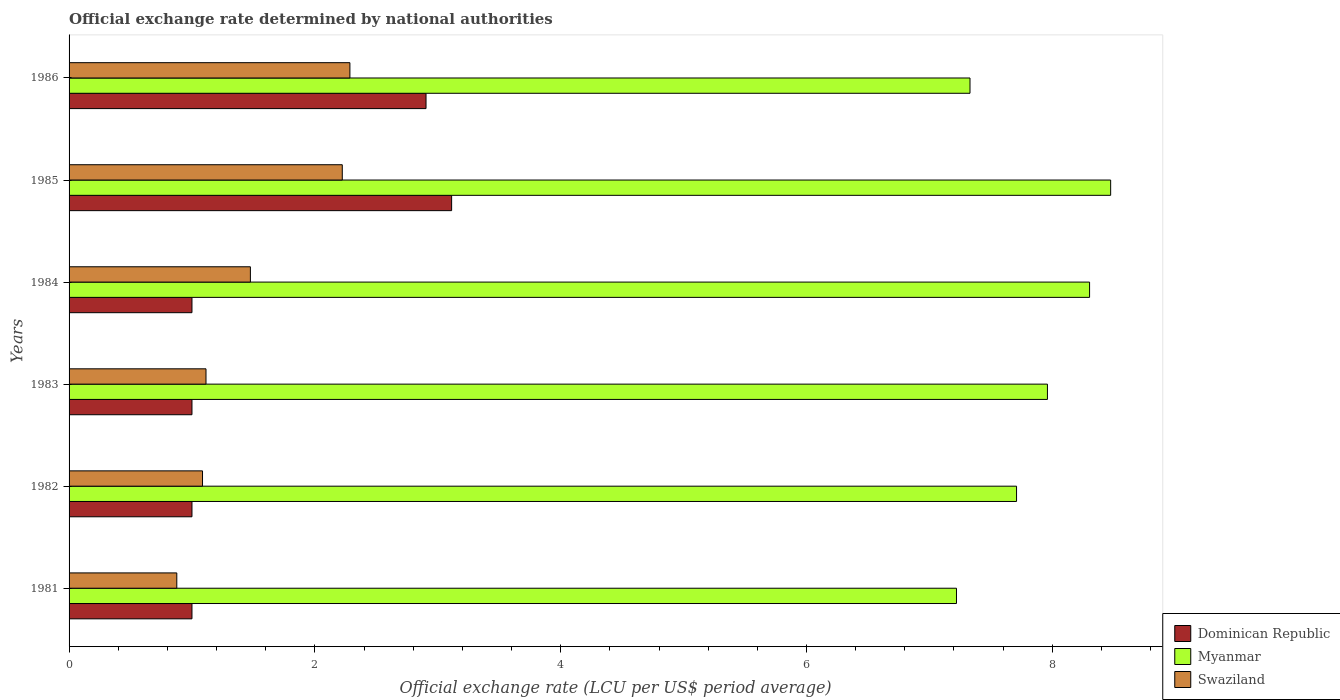Are the number of bars per tick equal to the number of legend labels?
Make the answer very short. Yes. What is the label of the 6th group of bars from the top?
Provide a succinct answer. 1981. In how many cases, is the number of bars for a given year not equal to the number of legend labels?
Your answer should be very brief. 0. What is the official exchange rate in Swaziland in 1982?
Offer a very short reply. 1.09. Across all years, what is the maximum official exchange rate in Myanmar?
Provide a short and direct response. 8.47. Across all years, what is the minimum official exchange rate in Swaziland?
Ensure brevity in your answer.  0.88. In which year was the official exchange rate in Swaziland maximum?
Your answer should be very brief. 1986. In which year was the official exchange rate in Swaziland minimum?
Offer a very short reply. 1981. What is the total official exchange rate in Myanmar in the graph?
Keep it short and to the point. 47. What is the difference between the official exchange rate in Swaziland in 1982 and that in 1984?
Give a very brief answer. -0.39. What is the difference between the official exchange rate in Myanmar in 1981 and the official exchange rate in Swaziland in 1983?
Keep it short and to the point. 6.11. What is the average official exchange rate in Myanmar per year?
Provide a short and direct response. 7.83. In the year 1981, what is the difference between the official exchange rate in Swaziland and official exchange rate in Myanmar?
Provide a short and direct response. -6.34. Is the official exchange rate in Myanmar in 1981 less than that in 1983?
Make the answer very short. Yes. What is the difference between the highest and the second highest official exchange rate in Swaziland?
Keep it short and to the point. 0.06. What is the difference between the highest and the lowest official exchange rate in Swaziland?
Provide a succinct answer. 1.41. In how many years, is the official exchange rate in Dominican Republic greater than the average official exchange rate in Dominican Republic taken over all years?
Offer a very short reply. 2. Is the sum of the official exchange rate in Swaziland in 1983 and 1984 greater than the maximum official exchange rate in Dominican Republic across all years?
Provide a short and direct response. No. What does the 1st bar from the top in 1981 represents?
Your answer should be very brief. Swaziland. What does the 3rd bar from the bottom in 1985 represents?
Offer a very short reply. Swaziland. How many bars are there?
Provide a succinct answer. 18. Are all the bars in the graph horizontal?
Offer a very short reply. Yes. What is the difference between two consecutive major ticks on the X-axis?
Provide a succinct answer. 2. Are the values on the major ticks of X-axis written in scientific E-notation?
Give a very brief answer. No. Where does the legend appear in the graph?
Provide a succinct answer. Bottom right. What is the title of the graph?
Make the answer very short. Official exchange rate determined by national authorities. What is the label or title of the X-axis?
Give a very brief answer. Official exchange rate (LCU per US$ period average). What is the label or title of the Y-axis?
Make the answer very short. Years. What is the Official exchange rate (LCU per US$ period average) of Dominican Republic in 1981?
Your answer should be compact. 1. What is the Official exchange rate (LCU per US$ period average) in Myanmar in 1981?
Give a very brief answer. 7.22. What is the Official exchange rate (LCU per US$ period average) in Swaziland in 1981?
Keep it short and to the point. 0.88. What is the Official exchange rate (LCU per US$ period average) of Dominican Republic in 1982?
Provide a succinct answer. 1. What is the Official exchange rate (LCU per US$ period average) of Myanmar in 1982?
Provide a short and direct response. 7.71. What is the Official exchange rate (LCU per US$ period average) of Swaziland in 1982?
Make the answer very short. 1.09. What is the Official exchange rate (LCU per US$ period average) of Dominican Republic in 1983?
Provide a short and direct response. 1. What is the Official exchange rate (LCU per US$ period average) in Myanmar in 1983?
Provide a short and direct response. 7.96. What is the Official exchange rate (LCU per US$ period average) in Swaziland in 1983?
Provide a succinct answer. 1.11. What is the Official exchange rate (LCU per US$ period average) of Dominican Republic in 1984?
Give a very brief answer. 1. What is the Official exchange rate (LCU per US$ period average) of Myanmar in 1984?
Keep it short and to the point. 8.3. What is the Official exchange rate (LCU per US$ period average) in Swaziland in 1984?
Ensure brevity in your answer.  1.48. What is the Official exchange rate (LCU per US$ period average) of Dominican Republic in 1985?
Make the answer very short. 3.11. What is the Official exchange rate (LCU per US$ period average) of Myanmar in 1985?
Keep it short and to the point. 8.47. What is the Official exchange rate (LCU per US$ period average) in Swaziland in 1985?
Your response must be concise. 2.22. What is the Official exchange rate (LCU per US$ period average) in Dominican Republic in 1986?
Give a very brief answer. 2.9. What is the Official exchange rate (LCU per US$ period average) of Myanmar in 1986?
Your response must be concise. 7.33. What is the Official exchange rate (LCU per US$ period average) in Swaziland in 1986?
Make the answer very short. 2.29. Across all years, what is the maximum Official exchange rate (LCU per US$ period average) of Dominican Republic?
Make the answer very short. 3.11. Across all years, what is the maximum Official exchange rate (LCU per US$ period average) of Myanmar?
Your response must be concise. 8.47. Across all years, what is the maximum Official exchange rate (LCU per US$ period average) in Swaziland?
Offer a very short reply. 2.29. Across all years, what is the minimum Official exchange rate (LCU per US$ period average) in Dominican Republic?
Offer a very short reply. 1. Across all years, what is the minimum Official exchange rate (LCU per US$ period average) of Myanmar?
Give a very brief answer. 7.22. Across all years, what is the minimum Official exchange rate (LCU per US$ period average) in Swaziland?
Offer a terse response. 0.88. What is the total Official exchange rate (LCU per US$ period average) of Dominican Republic in the graph?
Provide a succinct answer. 10.02. What is the total Official exchange rate (LCU per US$ period average) of Myanmar in the graph?
Provide a short and direct response. 47. What is the total Official exchange rate (LCU per US$ period average) in Swaziland in the graph?
Provide a succinct answer. 9.06. What is the difference between the Official exchange rate (LCU per US$ period average) of Myanmar in 1981 and that in 1982?
Offer a very short reply. -0.49. What is the difference between the Official exchange rate (LCU per US$ period average) in Swaziland in 1981 and that in 1982?
Your response must be concise. -0.21. What is the difference between the Official exchange rate (LCU per US$ period average) in Dominican Republic in 1981 and that in 1983?
Make the answer very short. 0. What is the difference between the Official exchange rate (LCU per US$ period average) of Myanmar in 1981 and that in 1983?
Provide a short and direct response. -0.74. What is the difference between the Official exchange rate (LCU per US$ period average) of Swaziland in 1981 and that in 1983?
Provide a succinct answer. -0.24. What is the difference between the Official exchange rate (LCU per US$ period average) of Dominican Republic in 1981 and that in 1984?
Your answer should be very brief. -0. What is the difference between the Official exchange rate (LCU per US$ period average) in Myanmar in 1981 and that in 1984?
Make the answer very short. -1.08. What is the difference between the Official exchange rate (LCU per US$ period average) in Swaziland in 1981 and that in 1984?
Offer a very short reply. -0.6. What is the difference between the Official exchange rate (LCU per US$ period average) of Dominican Republic in 1981 and that in 1985?
Your answer should be compact. -2.11. What is the difference between the Official exchange rate (LCU per US$ period average) in Myanmar in 1981 and that in 1985?
Offer a terse response. -1.25. What is the difference between the Official exchange rate (LCU per US$ period average) of Swaziland in 1981 and that in 1985?
Keep it short and to the point. -1.35. What is the difference between the Official exchange rate (LCU per US$ period average) of Dominican Republic in 1981 and that in 1986?
Your answer should be compact. -1.9. What is the difference between the Official exchange rate (LCU per US$ period average) of Myanmar in 1981 and that in 1986?
Your response must be concise. -0.11. What is the difference between the Official exchange rate (LCU per US$ period average) of Swaziland in 1981 and that in 1986?
Provide a short and direct response. -1.41. What is the difference between the Official exchange rate (LCU per US$ period average) in Dominican Republic in 1982 and that in 1983?
Your answer should be compact. 0. What is the difference between the Official exchange rate (LCU per US$ period average) in Myanmar in 1982 and that in 1983?
Your answer should be compact. -0.25. What is the difference between the Official exchange rate (LCU per US$ period average) in Swaziland in 1982 and that in 1983?
Provide a short and direct response. -0.03. What is the difference between the Official exchange rate (LCU per US$ period average) in Dominican Republic in 1982 and that in 1984?
Give a very brief answer. -0. What is the difference between the Official exchange rate (LCU per US$ period average) of Myanmar in 1982 and that in 1984?
Keep it short and to the point. -0.59. What is the difference between the Official exchange rate (LCU per US$ period average) in Swaziland in 1982 and that in 1984?
Your answer should be compact. -0.39. What is the difference between the Official exchange rate (LCU per US$ period average) in Dominican Republic in 1982 and that in 1985?
Ensure brevity in your answer.  -2.11. What is the difference between the Official exchange rate (LCU per US$ period average) of Myanmar in 1982 and that in 1985?
Provide a succinct answer. -0.77. What is the difference between the Official exchange rate (LCU per US$ period average) of Swaziland in 1982 and that in 1985?
Your answer should be compact. -1.14. What is the difference between the Official exchange rate (LCU per US$ period average) in Dominican Republic in 1982 and that in 1986?
Provide a short and direct response. -1.9. What is the difference between the Official exchange rate (LCU per US$ period average) in Myanmar in 1982 and that in 1986?
Offer a terse response. 0.38. What is the difference between the Official exchange rate (LCU per US$ period average) of Swaziland in 1982 and that in 1986?
Your answer should be compact. -1.2. What is the difference between the Official exchange rate (LCU per US$ period average) of Myanmar in 1983 and that in 1984?
Provide a succinct answer. -0.34. What is the difference between the Official exchange rate (LCU per US$ period average) of Swaziland in 1983 and that in 1984?
Your answer should be very brief. -0.36. What is the difference between the Official exchange rate (LCU per US$ period average) of Dominican Republic in 1983 and that in 1985?
Your answer should be compact. -2.11. What is the difference between the Official exchange rate (LCU per US$ period average) in Myanmar in 1983 and that in 1985?
Give a very brief answer. -0.51. What is the difference between the Official exchange rate (LCU per US$ period average) in Swaziland in 1983 and that in 1985?
Provide a short and direct response. -1.11. What is the difference between the Official exchange rate (LCU per US$ period average) in Dominican Republic in 1983 and that in 1986?
Provide a short and direct response. -1.9. What is the difference between the Official exchange rate (LCU per US$ period average) of Myanmar in 1983 and that in 1986?
Make the answer very short. 0.63. What is the difference between the Official exchange rate (LCU per US$ period average) of Swaziland in 1983 and that in 1986?
Keep it short and to the point. -1.17. What is the difference between the Official exchange rate (LCU per US$ period average) of Dominican Republic in 1984 and that in 1985?
Your answer should be very brief. -2.11. What is the difference between the Official exchange rate (LCU per US$ period average) in Myanmar in 1984 and that in 1985?
Your answer should be compact. -0.17. What is the difference between the Official exchange rate (LCU per US$ period average) of Swaziland in 1984 and that in 1985?
Offer a very short reply. -0.75. What is the difference between the Official exchange rate (LCU per US$ period average) in Dominican Republic in 1984 and that in 1986?
Keep it short and to the point. -1.9. What is the difference between the Official exchange rate (LCU per US$ period average) in Myanmar in 1984 and that in 1986?
Keep it short and to the point. 0.97. What is the difference between the Official exchange rate (LCU per US$ period average) of Swaziland in 1984 and that in 1986?
Ensure brevity in your answer.  -0.81. What is the difference between the Official exchange rate (LCU per US$ period average) in Dominican Republic in 1985 and that in 1986?
Make the answer very short. 0.21. What is the difference between the Official exchange rate (LCU per US$ period average) of Myanmar in 1985 and that in 1986?
Ensure brevity in your answer.  1.14. What is the difference between the Official exchange rate (LCU per US$ period average) of Swaziland in 1985 and that in 1986?
Your answer should be very brief. -0.06. What is the difference between the Official exchange rate (LCU per US$ period average) of Dominican Republic in 1981 and the Official exchange rate (LCU per US$ period average) of Myanmar in 1982?
Offer a very short reply. -6.71. What is the difference between the Official exchange rate (LCU per US$ period average) in Dominican Republic in 1981 and the Official exchange rate (LCU per US$ period average) in Swaziland in 1982?
Your answer should be compact. -0.09. What is the difference between the Official exchange rate (LCU per US$ period average) in Myanmar in 1981 and the Official exchange rate (LCU per US$ period average) in Swaziland in 1982?
Offer a terse response. 6.13. What is the difference between the Official exchange rate (LCU per US$ period average) of Dominican Republic in 1981 and the Official exchange rate (LCU per US$ period average) of Myanmar in 1983?
Give a very brief answer. -6.96. What is the difference between the Official exchange rate (LCU per US$ period average) in Dominican Republic in 1981 and the Official exchange rate (LCU per US$ period average) in Swaziland in 1983?
Ensure brevity in your answer.  -0.11. What is the difference between the Official exchange rate (LCU per US$ period average) of Myanmar in 1981 and the Official exchange rate (LCU per US$ period average) of Swaziland in 1983?
Your answer should be very brief. 6.11. What is the difference between the Official exchange rate (LCU per US$ period average) of Dominican Republic in 1981 and the Official exchange rate (LCU per US$ period average) of Myanmar in 1984?
Your answer should be very brief. -7.3. What is the difference between the Official exchange rate (LCU per US$ period average) of Dominican Republic in 1981 and the Official exchange rate (LCU per US$ period average) of Swaziland in 1984?
Keep it short and to the point. -0.48. What is the difference between the Official exchange rate (LCU per US$ period average) of Myanmar in 1981 and the Official exchange rate (LCU per US$ period average) of Swaziland in 1984?
Provide a short and direct response. 5.75. What is the difference between the Official exchange rate (LCU per US$ period average) in Dominican Republic in 1981 and the Official exchange rate (LCU per US$ period average) in Myanmar in 1985?
Provide a short and direct response. -7.47. What is the difference between the Official exchange rate (LCU per US$ period average) in Dominican Republic in 1981 and the Official exchange rate (LCU per US$ period average) in Swaziland in 1985?
Your response must be concise. -1.22. What is the difference between the Official exchange rate (LCU per US$ period average) in Myanmar in 1981 and the Official exchange rate (LCU per US$ period average) in Swaziland in 1985?
Provide a short and direct response. 5. What is the difference between the Official exchange rate (LCU per US$ period average) of Dominican Republic in 1981 and the Official exchange rate (LCU per US$ period average) of Myanmar in 1986?
Provide a short and direct response. -6.33. What is the difference between the Official exchange rate (LCU per US$ period average) of Dominican Republic in 1981 and the Official exchange rate (LCU per US$ period average) of Swaziland in 1986?
Make the answer very short. -1.28. What is the difference between the Official exchange rate (LCU per US$ period average) in Myanmar in 1981 and the Official exchange rate (LCU per US$ period average) in Swaziland in 1986?
Offer a terse response. 4.94. What is the difference between the Official exchange rate (LCU per US$ period average) of Dominican Republic in 1982 and the Official exchange rate (LCU per US$ period average) of Myanmar in 1983?
Your answer should be compact. -6.96. What is the difference between the Official exchange rate (LCU per US$ period average) of Dominican Republic in 1982 and the Official exchange rate (LCU per US$ period average) of Swaziland in 1983?
Make the answer very short. -0.11. What is the difference between the Official exchange rate (LCU per US$ period average) in Myanmar in 1982 and the Official exchange rate (LCU per US$ period average) in Swaziland in 1983?
Provide a short and direct response. 6.59. What is the difference between the Official exchange rate (LCU per US$ period average) of Dominican Republic in 1982 and the Official exchange rate (LCU per US$ period average) of Myanmar in 1984?
Offer a very short reply. -7.3. What is the difference between the Official exchange rate (LCU per US$ period average) of Dominican Republic in 1982 and the Official exchange rate (LCU per US$ period average) of Swaziland in 1984?
Make the answer very short. -0.48. What is the difference between the Official exchange rate (LCU per US$ period average) of Myanmar in 1982 and the Official exchange rate (LCU per US$ period average) of Swaziland in 1984?
Provide a short and direct response. 6.23. What is the difference between the Official exchange rate (LCU per US$ period average) in Dominican Republic in 1982 and the Official exchange rate (LCU per US$ period average) in Myanmar in 1985?
Keep it short and to the point. -7.47. What is the difference between the Official exchange rate (LCU per US$ period average) in Dominican Republic in 1982 and the Official exchange rate (LCU per US$ period average) in Swaziland in 1985?
Offer a terse response. -1.22. What is the difference between the Official exchange rate (LCU per US$ period average) in Myanmar in 1982 and the Official exchange rate (LCU per US$ period average) in Swaziland in 1985?
Offer a terse response. 5.49. What is the difference between the Official exchange rate (LCU per US$ period average) in Dominican Republic in 1982 and the Official exchange rate (LCU per US$ period average) in Myanmar in 1986?
Provide a succinct answer. -6.33. What is the difference between the Official exchange rate (LCU per US$ period average) in Dominican Republic in 1982 and the Official exchange rate (LCU per US$ period average) in Swaziland in 1986?
Give a very brief answer. -1.28. What is the difference between the Official exchange rate (LCU per US$ period average) of Myanmar in 1982 and the Official exchange rate (LCU per US$ period average) of Swaziland in 1986?
Make the answer very short. 5.42. What is the difference between the Official exchange rate (LCU per US$ period average) in Dominican Republic in 1983 and the Official exchange rate (LCU per US$ period average) in Myanmar in 1984?
Your response must be concise. -7.3. What is the difference between the Official exchange rate (LCU per US$ period average) in Dominican Republic in 1983 and the Official exchange rate (LCU per US$ period average) in Swaziland in 1984?
Offer a very short reply. -0.48. What is the difference between the Official exchange rate (LCU per US$ period average) of Myanmar in 1983 and the Official exchange rate (LCU per US$ period average) of Swaziland in 1984?
Your answer should be compact. 6.49. What is the difference between the Official exchange rate (LCU per US$ period average) in Dominican Republic in 1983 and the Official exchange rate (LCU per US$ period average) in Myanmar in 1985?
Your answer should be compact. -7.47. What is the difference between the Official exchange rate (LCU per US$ period average) in Dominican Republic in 1983 and the Official exchange rate (LCU per US$ period average) in Swaziland in 1985?
Your response must be concise. -1.22. What is the difference between the Official exchange rate (LCU per US$ period average) in Myanmar in 1983 and the Official exchange rate (LCU per US$ period average) in Swaziland in 1985?
Your answer should be very brief. 5.74. What is the difference between the Official exchange rate (LCU per US$ period average) of Dominican Republic in 1983 and the Official exchange rate (LCU per US$ period average) of Myanmar in 1986?
Offer a very short reply. -6.33. What is the difference between the Official exchange rate (LCU per US$ period average) of Dominican Republic in 1983 and the Official exchange rate (LCU per US$ period average) of Swaziland in 1986?
Your answer should be very brief. -1.28. What is the difference between the Official exchange rate (LCU per US$ period average) of Myanmar in 1983 and the Official exchange rate (LCU per US$ period average) of Swaziland in 1986?
Your answer should be compact. 5.68. What is the difference between the Official exchange rate (LCU per US$ period average) of Dominican Republic in 1984 and the Official exchange rate (LCU per US$ period average) of Myanmar in 1985?
Give a very brief answer. -7.47. What is the difference between the Official exchange rate (LCU per US$ period average) in Dominican Republic in 1984 and the Official exchange rate (LCU per US$ period average) in Swaziland in 1985?
Give a very brief answer. -1.22. What is the difference between the Official exchange rate (LCU per US$ period average) in Myanmar in 1984 and the Official exchange rate (LCU per US$ period average) in Swaziland in 1985?
Your answer should be very brief. 6.08. What is the difference between the Official exchange rate (LCU per US$ period average) in Dominican Republic in 1984 and the Official exchange rate (LCU per US$ period average) in Myanmar in 1986?
Keep it short and to the point. -6.33. What is the difference between the Official exchange rate (LCU per US$ period average) of Dominican Republic in 1984 and the Official exchange rate (LCU per US$ period average) of Swaziland in 1986?
Your answer should be very brief. -1.28. What is the difference between the Official exchange rate (LCU per US$ period average) of Myanmar in 1984 and the Official exchange rate (LCU per US$ period average) of Swaziland in 1986?
Keep it short and to the point. 6.02. What is the difference between the Official exchange rate (LCU per US$ period average) of Dominican Republic in 1985 and the Official exchange rate (LCU per US$ period average) of Myanmar in 1986?
Your answer should be very brief. -4.22. What is the difference between the Official exchange rate (LCU per US$ period average) of Dominican Republic in 1985 and the Official exchange rate (LCU per US$ period average) of Swaziland in 1986?
Your answer should be very brief. 0.83. What is the difference between the Official exchange rate (LCU per US$ period average) in Myanmar in 1985 and the Official exchange rate (LCU per US$ period average) in Swaziland in 1986?
Give a very brief answer. 6.19. What is the average Official exchange rate (LCU per US$ period average) of Dominican Republic per year?
Your answer should be very brief. 1.67. What is the average Official exchange rate (LCU per US$ period average) in Myanmar per year?
Offer a very short reply. 7.83. What is the average Official exchange rate (LCU per US$ period average) of Swaziland per year?
Offer a very short reply. 1.51. In the year 1981, what is the difference between the Official exchange rate (LCU per US$ period average) in Dominican Republic and Official exchange rate (LCU per US$ period average) in Myanmar?
Keep it short and to the point. -6.22. In the year 1981, what is the difference between the Official exchange rate (LCU per US$ period average) in Dominican Republic and Official exchange rate (LCU per US$ period average) in Swaziland?
Provide a short and direct response. 0.12. In the year 1981, what is the difference between the Official exchange rate (LCU per US$ period average) in Myanmar and Official exchange rate (LCU per US$ period average) in Swaziland?
Your answer should be compact. 6.34. In the year 1982, what is the difference between the Official exchange rate (LCU per US$ period average) of Dominican Republic and Official exchange rate (LCU per US$ period average) of Myanmar?
Provide a succinct answer. -6.71. In the year 1982, what is the difference between the Official exchange rate (LCU per US$ period average) of Dominican Republic and Official exchange rate (LCU per US$ period average) of Swaziland?
Keep it short and to the point. -0.09. In the year 1982, what is the difference between the Official exchange rate (LCU per US$ period average) in Myanmar and Official exchange rate (LCU per US$ period average) in Swaziland?
Give a very brief answer. 6.62. In the year 1983, what is the difference between the Official exchange rate (LCU per US$ period average) of Dominican Republic and Official exchange rate (LCU per US$ period average) of Myanmar?
Offer a very short reply. -6.96. In the year 1983, what is the difference between the Official exchange rate (LCU per US$ period average) of Dominican Republic and Official exchange rate (LCU per US$ period average) of Swaziland?
Provide a succinct answer. -0.11. In the year 1983, what is the difference between the Official exchange rate (LCU per US$ period average) in Myanmar and Official exchange rate (LCU per US$ period average) in Swaziland?
Make the answer very short. 6.85. In the year 1984, what is the difference between the Official exchange rate (LCU per US$ period average) of Dominican Republic and Official exchange rate (LCU per US$ period average) of Myanmar?
Offer a very short reply. -7.3. In the year 1984, what is the difference between the Official exchange rate (LCU per US$ period average) of Dominican Republic and Official exchange rate (LCU per US$ period average) of Swaziland?
Give a very brief answer. -0.48. In the year 1984, what is the difference between the Official exchange rate (LCU per US$ period average) of Myanmar and Official exchange rate (LCU per US$ period average) of Swaziland?
Your response must be concise. 6.83. In the year 1985, what is the difference between the Official exchange rate (LCU per US$ period average) of Dominican Republic and Official exchange rate (LCU per US$ period average) of Myanmar?
Provide a short and direct response. -5.36. In the year 1985, what is the difference between the Official exchange rate (LCU per US$ period average) in Dominican Republic and Official exchange rate (LCU per US$ period average) in Swaziland?
Offer a terse response. 0.89. In the year 1985, what is the difference between the Official exchange rate (LCU per US$ period average) of Myanmar and Official exchange rate (LCU per US$ period average) of Swaziland?
Make the answer very short. 6.25. In the year 1986, what is the difference between the Official exchange rate (LCU per US$ period average) in Dominican Republic and Official exchange rate (LCU per US$ period average) in Myanmar?
Offer a terse response. -4.43. In the year 1986, what is the difference between the Official exchange rate (LCU per US$ period average) in Dominican Republic and Official exchange rate (LCU per US$ period average) in Swaziland?
Your answer should be compact. 0.62. In the year 1986, what is the difference between the Official exchange rate (LCU per US$ period average) in Myanmar and Official exchange rate (LCU per US$ period average) in Swaziland?
Offer a very short reply. 5.05. What is the ratio of the Official exchange rate (LCU per US$ period average) in Myanmar in 1981 to that in 1982?
Ensure brevity in your answer.  0.94. What is the ratio of the Official exchange rate (LCU per US$ period average) in Swaziland in 1981 to that in 1982?
Your answer should be compact. 0.81. What is the ratio of the Official exchange rate (LCU per US$ period average) of Dominican Republic in 1981 to that in 1983?
Your answer should be very brief. 1. What is the ratio of the Official exchange rate (LCU per US$ period average) of Myanmar in 1981 to that in 1983?
Give a very brief answer. 0.91. What is the ratio of the Official exchange rate (LCU per US$ period average) of Swaziland in 1981 to that in 1983?
Keep it short and to the point. 0.79. What is the ratio of the Official exchange rate (LCU per US$ period average) of Dominican Republic in 1981 to that in 1984?
Provide a short and direct response. 1. What is the ratio of the Official exchange rate (LCU per US$ period average) in Myanmar in 1981 to that in 1984?
Provide a succinct answer. 0.87. What is the ratio of the Official exchange rate (LCU per US$ period average) in Swaziland in 1981 to that in 1984?
Ensure brevity in your answer.  0.59. What is the ratio of the Official exchange rate (LCU per US$ period average) of Dominican Republic in 1981 to that in 1985?
Provide a succinct answer. 0.32. What is the ratio of the Official exchange rate (LCU per US$ period average) in Myanmar in 1981 to that in 1985?
Give a very brief answer. 0.85. What is the ratio of the Official exchange rate (LCU per US$ period average) in Swaziland in 1981 to that in 1985?
Your response must be concise. 0.39. What is the ratio of the Official exchange rate (LCU per US$ period average) of Dominican Republic in 1981 to that in 1986?
Ensure brevity in your answer.  0.34. What is the ratio of the Official exchange rate (LCU per US$ period average) in Swaziland in 1981 to that in 1986?
Make the answer very short. 0.38. What is the ratio of the Official exchange rate (LCU per US$ period average) in Myanmar in 1982 to that in 1983?
Your answer should be compact. 0.97. What is the ratio of the Official exchange rate (LCU per US$ period average) of Swaziland in 1982 to that in 1983?
Provide a succinct answer. 0.97. What is the ratio of the Official exchange rate (LCU per US$ period average) in Myanmar in 1982 to that in 1984?
Ensure brevity in your answer.  0.93. What is the ratio of the Official exchange rate (LCU per US$ period average) in Swaziland in 1982 to that in 1984?
Provide a succinct answer. 0.74. What is the ratio of the Official exchange rate (LCU per US$ period average) in Dominican Republic in 1982 to that in 1985?
Make the answer very short. 0.32. What is the ratio of the Official exchange rate (LCU per US$ period average) of Myanmar in 1982 to that in 1985?
Your answer should be very brief. 0.91. What is the ratio of the Official exchange rate (LCU per US$ period average) in Swaziland in 1982 to that in 1985?
Your answer should be compact. 0.49. What is the ratio of the Official exchange rate (LCU per US$ period average) in Dominican Republic in 1982 to that in 1986?
Ensure brevity in your answer.  0.34. What is the ratio of the Official exchange rate (LCU per US$ period average) of Myanmar in 1982 to that in 1986?
Make the answer very short. 1.05. What is the ratio of the Official exchange rate (LCU per US$ period average) of Swaziland in 1982 to that in 1986?
Ensure brevity in your answer.  0.48. What is the ratio of the Official exchange rate (LCU per US$ period average) of Dominican Republic in 1983 to that in 1984?
Make the answer very short. 1. What is the ratio of the Official exchange rate (LCU per US$ period average) in Myanmar in 1983 to that in 1984?
Your answer should be compact. 0.96. What is the ratio of the Official exchange rate (LCU per US$ period average) of Swaziland in 1983 to that in 1984?
Offer a terse response. 0.76. What is the ratio of the Official exchange rate (LCU per US$ period average) of Dominican Republic in 1983 to that in 1985?
Ensure brevity in your answer.  0.32. What is the ratio of the Official exchange rate (LCU per US$ period average) of Myanmar in 1983 to that in 1985?
Offer a very short reply. 0.94. What is the ratio of the Official exchange rate (LCU per US$ period average) in Swaziland in 1983 to that in 1985?
Provide a short and direct response. 0.5. What is the ratio of the Official exchange rate (LCU per US$ period average) in Dominican Republic in 1983 to that in 1986?
Provide a succinct answer. 0.34. What is the ratio of the Official exchange rate (LCU per US$ period average) in Myanmar in 1983 to that in 1986?
Your answer should be very brief. 1.09. What is the ratio of the Official exchange rate (LCU per US$ period average) in Swaziland in 1983 to that in 1986?
Keep it short and to the point. 0.49. What is the ratio of the Official exchange rate (LCU per US$ period average) in Dominican Republic in 1984 to that in 1985?
Offer a very short reply. 0.32. What is the ratio of the Official exchange rate (LCU per US$ period average) in Myanmar in 1984 to that in 1985?
Provide a succinct answer. 0.98. What is the ratio of the Official exchange rate (LCU per US$ period average) in Swaziland in 1984 to that in 1985?
Make the answer very short. 0.66. What is the ratio of the Official exchange rate (LCU per US$ period average) of Dominican Republic in 1984 to that in 1986?
Offer a very short reply. 0.34. What is the ratio of the Official exchange rate (LCU per US$ period average) in Myanmar in 1984 to that in 1986?
Provide a short and direct response. 1.13. What is the ratio of the Official exchange rate (LCU per US$ period average) of Swaziland in 1984 to that in 1986?
Give a very brief answer. 0.65. What is the ratio of the Official exchange rate (LCU per US$ period average) of Dominican Republic in 1985 to that in 1986?
Your answer should be compact. 1.07. What is the ratio of the Official exchange rate (LCU per US$ period average) in Myanmar in 1985 to that in 1986?
Provide a succinct answer. 1.16. What is the ratio of the Official exchange rate (LCU per US$ period average) in Swaziland in 1985 to that in 1986?
Provide a succinct answer. 0.97. What is the difference between the highest and the second highest Official exchange rate (LCU per US$ period average) of Dominican Republic?
Your answer should be compact. 0.21. What is the difference between the highest and the second highest Official exchange rate (LCU per US$ period average) in Myanmar?
Your answer should be very brief. 0.17. What is the difference between the highest and the second highest Official exchange rate (LCU per US$ period average) of Swaziland?
Offer a terse response. 0.06. What is the difference between the highest and the lowest Official exchange rate (LCU per US$ period average) of Dominican Republic?
Ensure brevity in your answer.  2.11. What is the difference between the highest and the lowest Official exchange rate (LCU per US$ period average) in Myanmar?
Keep it short and to the point. 1.25. What is the difference between the highest and the lowest Official exchange rate (LCU per US$ period average) in Swaziland?
Your answer should be compact. 1.41. 